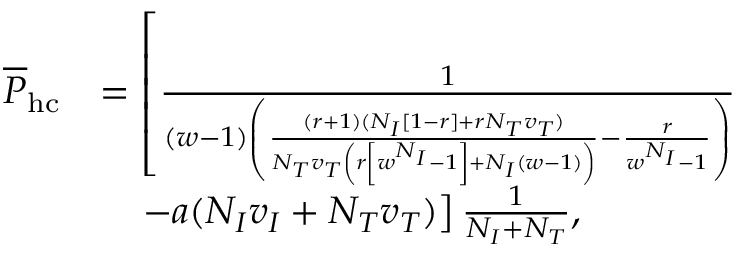Convert formula to latex. <formula><loc_0><loc_0><loc_500><loc_500>\begin{array} { r l } { \overline { P } _ { h c } } & { = \left [ \frac { 1 } { ( w - 1 ) \left ( \frac { ( r + 1 ) ( N _ { I } [ 1 - r ] + r N _ { T } v _ { T } ) } { N _ { T } v _ { T } \left ( r \left [ w ^ { N _ { I } } - 1 \right ] + N _ { I } ( w - 1 ) \right ) } - \frac { r } { w ^ { N _ { I } } - 1 } \right ) } } \\ & { \quad - a ( N _ { I } v _ { I } + N _ { T } v _ { T } ) \right ] \frac { 1 } { N _ { I } + N _ { T } } , } \end{array}</formula> 